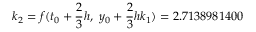Convert formula to latex. <formula><loc_0><loc_0><loc_500><loc_500>k _ { 2 } = f ( t _ { 0 } + { \frac { 2 } { 3 } } h , \ y _ { 0 } + { \frac { 2 } { 3 } } h k _ { 1 } ) = 2 . 7 1 3 8 9 8 1 4 0 0</formula> 